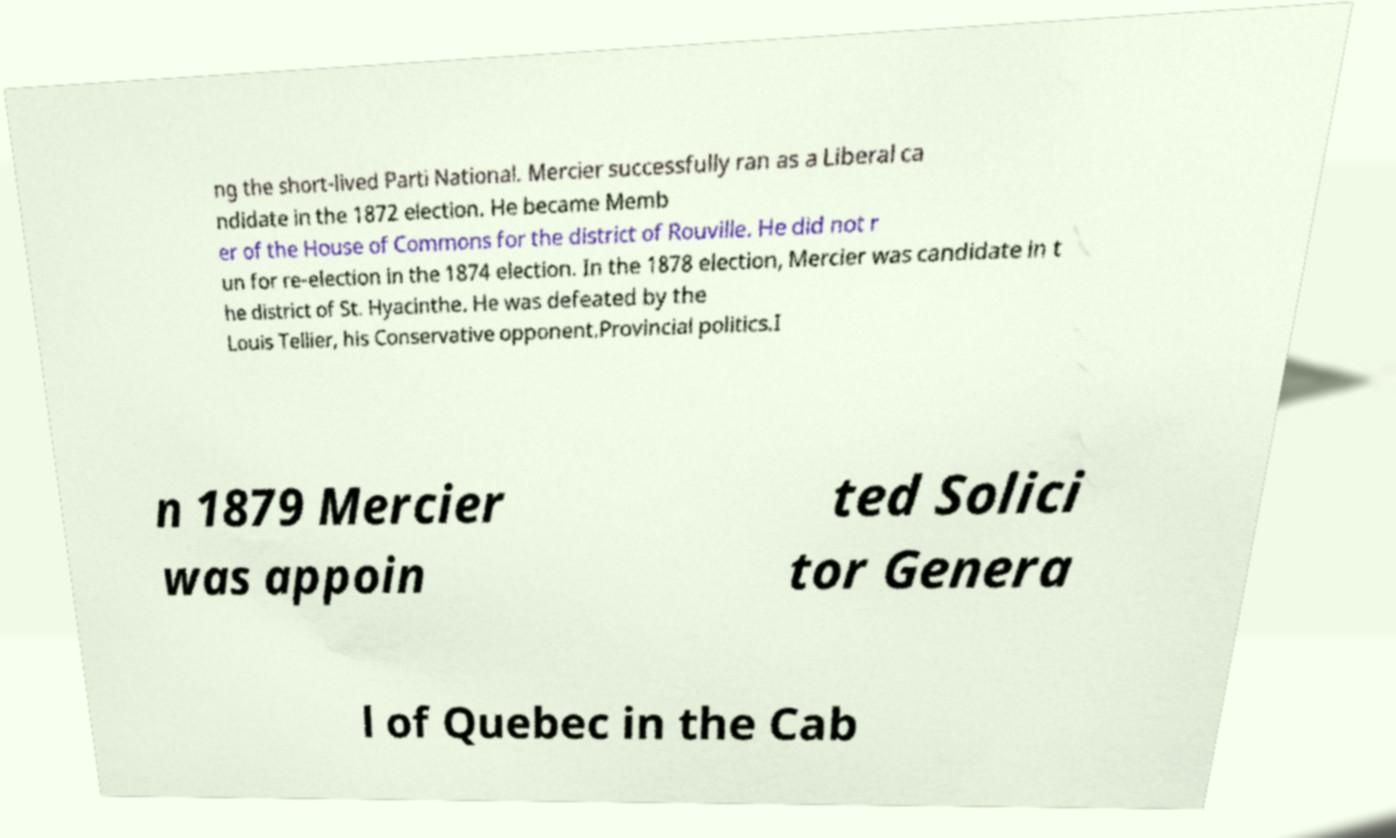For documentation purposes, I need the text within this image transcribed. Could you provide that? ng the short-lived Parti National. Mercier successfully ran as a Liberal ca ndidate in the 1872 election. He became Memb er of the House of Commons for the district of Rouville. He did not r un for re-election in the 1874 election. In the 1878 election, Mercier was candidate in t he district of St. Hyacinthe. He was defeated by the Louis Tellier, his Conservative opponent.Provincial politics.I n 1879 Mercier was appoin ted Solici tor Genera l of Quebec in the Cab 